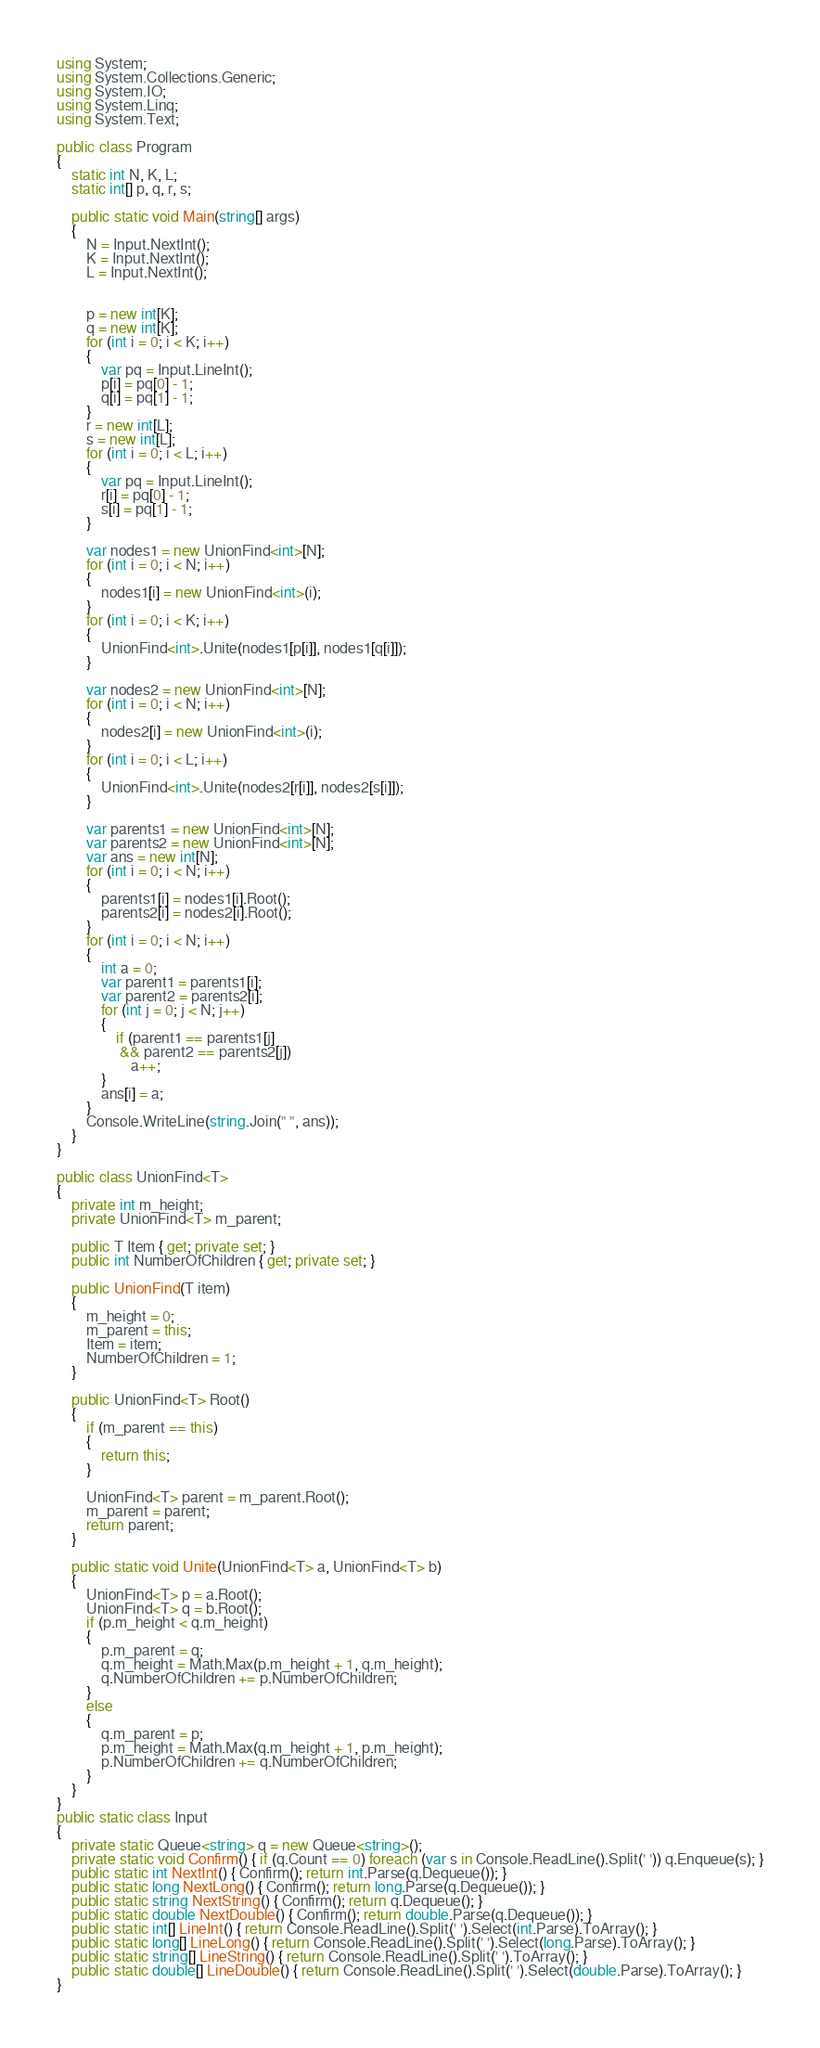<code> <loc_0><loc_0><loc_500><loc_500><_C#_>using System;
using System.Collections.Generic;
using System.IO;
using System.Linq;
using System.Text;

public class Program
{
    static int N, K, L;
    static int[] p, q, r, s;

    public static void Main(string[] args)
    {
        N = Input.NextInt();
        K = Input.NextInt();
        L = Input.NextInt();


        p = new int[K];
        q = new int[K];
        for (int i = 0; i < K; i++)
        {
            var pq = Input.LineInt();
            p[i] = pq[0] - 1;
            q[i] = pq[1] - 1;
        }
        r = new int[L];
        s = new int[L];
        for (int i = 0; i < L; i++)
        {
            var pq = Input.LineInt();
            r[i] = pq[0] - 1;
            s[i] = pq[1] - 1;
        }

        var nodes1 = new UnionFind<int>[N];
        for (int i = 0; i < N; i++)
        {
            nodes1[i] = new UnionFind<int>(i);
        }
        for (int i = 0; i < K; i++)
        {
            UnionFind<int>.Unite(nodes1[p[i]], nodes1[q[i]]);
        }

        var nodes2 = new UnionFind<int>[N];
        for (int i = 0; i < N; i++)
        {
            nodes2[i] = new UnionFind<int>(i);
        }
        for (int i = 0; i < L; i++)
        {
            UnionFind<int>.Unite(nodes2[r[i]], nodes2[s[i]]);
        }

        var parents1 = new UnionFind<int>[N];
        var parents2 = new UnionFind<int>[N];
        var ans = new int[N];
        for (int i = 0; i < N; i++)
        {
            parents1[i] = nodes1[i].Root();
            parents2[i] = nodes2[i].Root();
        }
        for (int i = 0; i < N; i++)
        {
            int a = 0;
            var parent1 = parents1[i];
            var parent2 = parents2[i];
            for (int j = 0; j < N; j++)
            {
                if (parent1 == parents1[j]
                 && parent2 == parents2[j])
                    a++;
            }
            ans[i] = a;
        }
        Console.WriteLine(string.Join(" ", ans));
    }
}

public class UnionFind<T>
{
    private int m_height;
    private UnionFind<T> m_parent;

    public T Item { get; private set; }
    public int NumberOfChildren { get; private set; }

    public UnionFind(T item)
    {
        m_height = 0;
        m_parent = this;
        Item = item;
        NumberOfChildren = 1;
    }

    public UnionFind<T> Root()
    {
        if (m_parent == this)
        {
            return this;
        }

        UnionFind<T> parent = m_parent.Root();
        m_parent = parent;
        return parent;
    }

    public static void Unite(UnionFind<T> a, UnionFind<T> b)
    {
        UnionFind<T> p = a.Root();
        UnionFind<T> q = b.Root();
        if (p.m_height < q.m_height)
        {
            p.m_parent = q;
            q.m_height = Math.Max(p.m_height + 1, q.m_height);
            q.NumberOfChildren += p.NumberOfChildren;
        }
        else
        {
            q.m_parent = p;
            p.m_height = Math.Max(q.m_height + 1, p.m_height);
            p.NumberOfChildren += q.NumberOfChildren;
        }
    }
}
public static class Input
{
    private static Queue<string> q = new Queue<string>();
    private static void Confirm() { if (q.Count == 0) foreach (var s in Console.ReadLine().Split(' ')) q.Enqueue(s); }
    public static int NextInt() { Confirm(); return int.Parse(q.Dequeue()); }
    public static long NextLong() { Confirm(); return long.Parse(q.Dequeue()); }
    public static string NextString() { Confirm(); return q.Dequeue(); }
    public static double NextDouble() { Confirm(); return double.Parse(q.Dequeue()); }
    public static int[] LineInt() { return Console.ReadLine().Split(' ').Select(int.Parse).ToArray(); }
    public static long[] LineLong() { return Console.ReadLine().Split(' ').Select(long.Parse).ToArray(); }
    public static string[] LineString() { return Console.ReadLine().Split(' ').ToArray(); }
    public static double[] LineDouble() { return Console.ReadLine().Split(' ').Select(double.Parse).ToArray(); }
}
</code> 